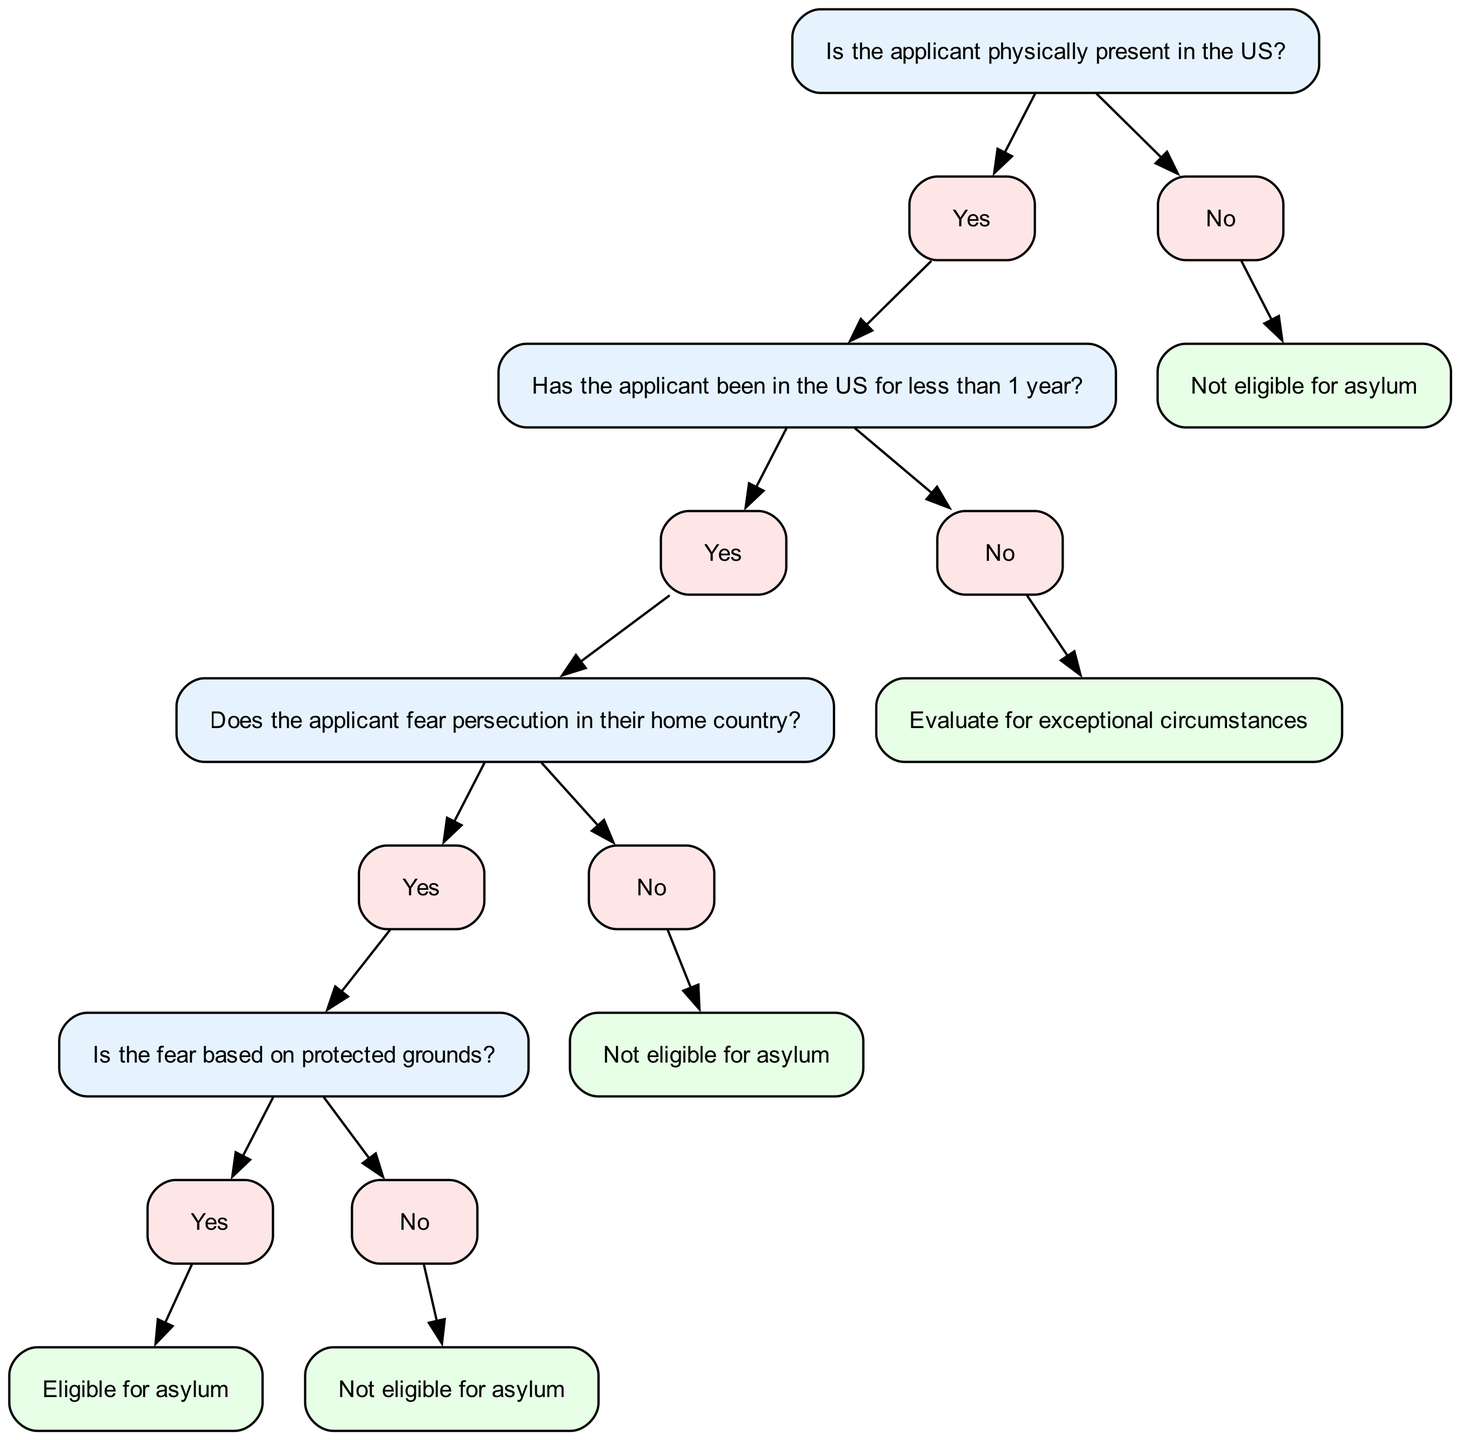What is the first question in the decision tree? The first question in the decision tree is posed at the root node, which asks if the applicant is physically present in the US.
Answer: Is the applicant physically present in the US? How many nodes are there in this decision tree? By counting all the nodes provided in the data, there is a total of 17 nodes in the diagram, starting from the root down to endpoint decisions.
Answer: 17 What happens if the applicant's fear of persecution is not based on protected grounds? If the applicant's fear of persecution is not based on protected grounds, they will be directed to the node that states "Not eligible for asylum." This is reached through the path after confirming they fear persecution.
Answer: Not eligible for asylum What is the outcome if the applicant has been in the US for longer than 1 year? If the applicant has been in the US for longer than 1 year, they will be directed to evaluate for exceptional circumstances, which will require an assessment of their specific situation.
Answer: Evaluate for exceptional circumstances What is the final decision if the applicant fears persecution based on protected grounds? If the applicant fears persecution and this fear is based on protected grounds, they are determined to be eligible for asylum. This follows from confirming both their fear and the basis of that fear.
Answer: Eligible for asylum What is the path for an applicant who is not physically present in the US? If the applicant is not physically present in the US, the decision tree directs them to a final outcome stating "Not eligible for asylum," indicating a straightforward denial of eligibility.
Answer: Not eligible for asylum If an applicant has been in the US for less than 1 year but does not fear persecution, what is their status? If the applicant has been in the US for less than 1 year and does not fear persecution, they will be directed to "Not eligible for asylum," confirming that lack of fear negates eligibility.
Answer: Not eligible for asylum What do you check after confirming that the applicant fears persecution? After confirming that the applicant fears persecution, the next check is whether that fear is based on protected grounds, which is crucial for determining eligibility for asylum.
Answer: Does the applicant fear persecution in their home country? 